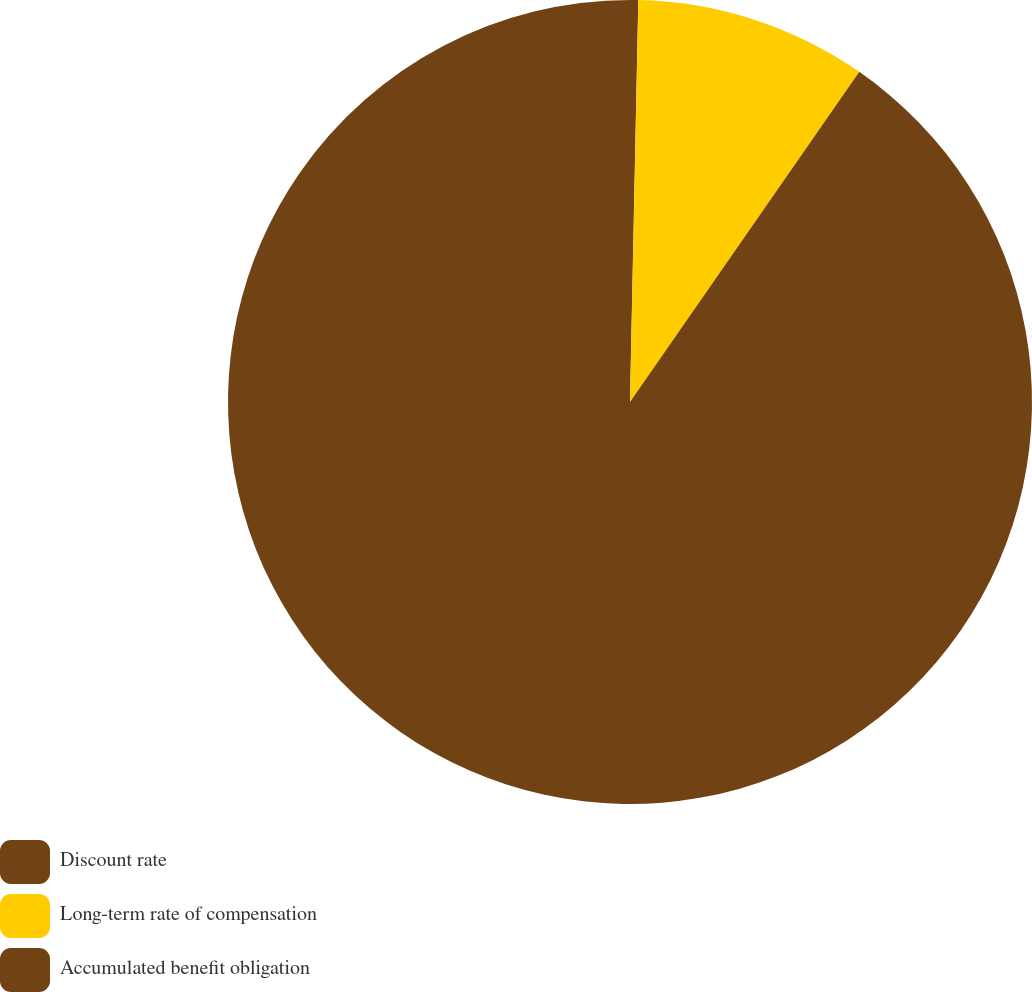Convert chart. <chart><loc_0><loc_0><loc_500><loc_500><pie_chart><fcel>Discount rate<fcel>Long-term rate of compensation<fcel>Accumulated benefit obligation<nl><fcel>0.33%<fcel>9.33%<fcel>90.33%<nl></chart> 